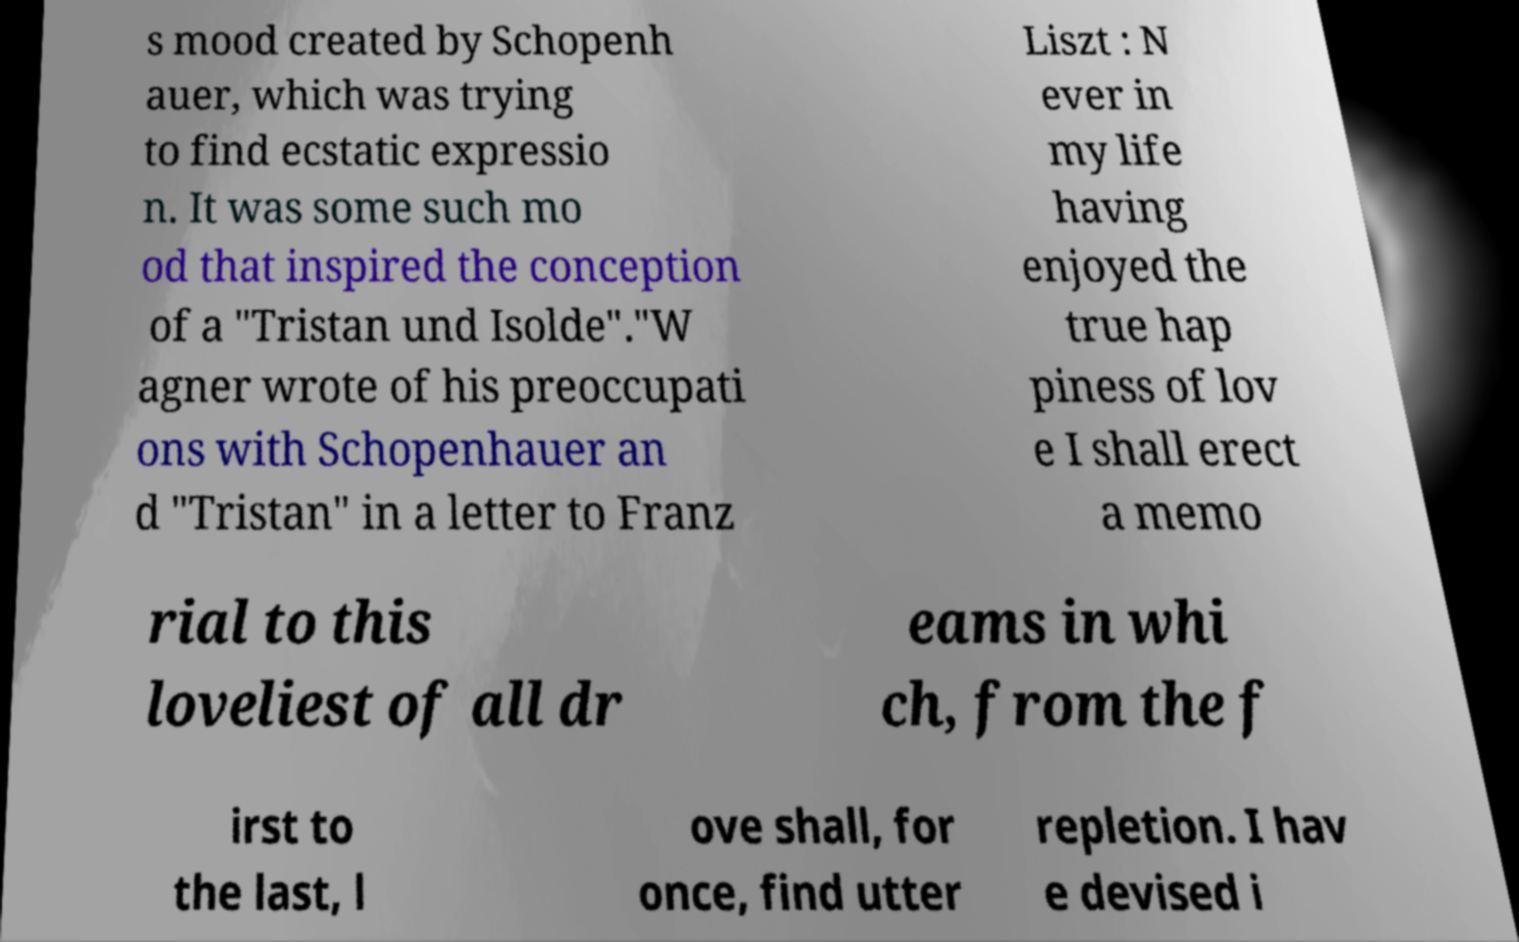Can you read and provide the text displayed in the image?This photo seems to have some interesting text. Can you extract and type it out for me? s mood created by Schopenh auer, which was trying to find ecstatic expressio n. It was some such mo od that inspired the conception of a "Tristan und Isolde"."W agner wrote of his preoccupati ons with Schopenhauer an d "Tristan" in a letter to Franz Liszt : N ever in my life having enjoyed the true hap piness of lov e I shall erect a memo rial to this loveliest of all dr eams in whi ch, from the f irst to the last, l ove shall, for once, find utter repletion. I hav e devised i 